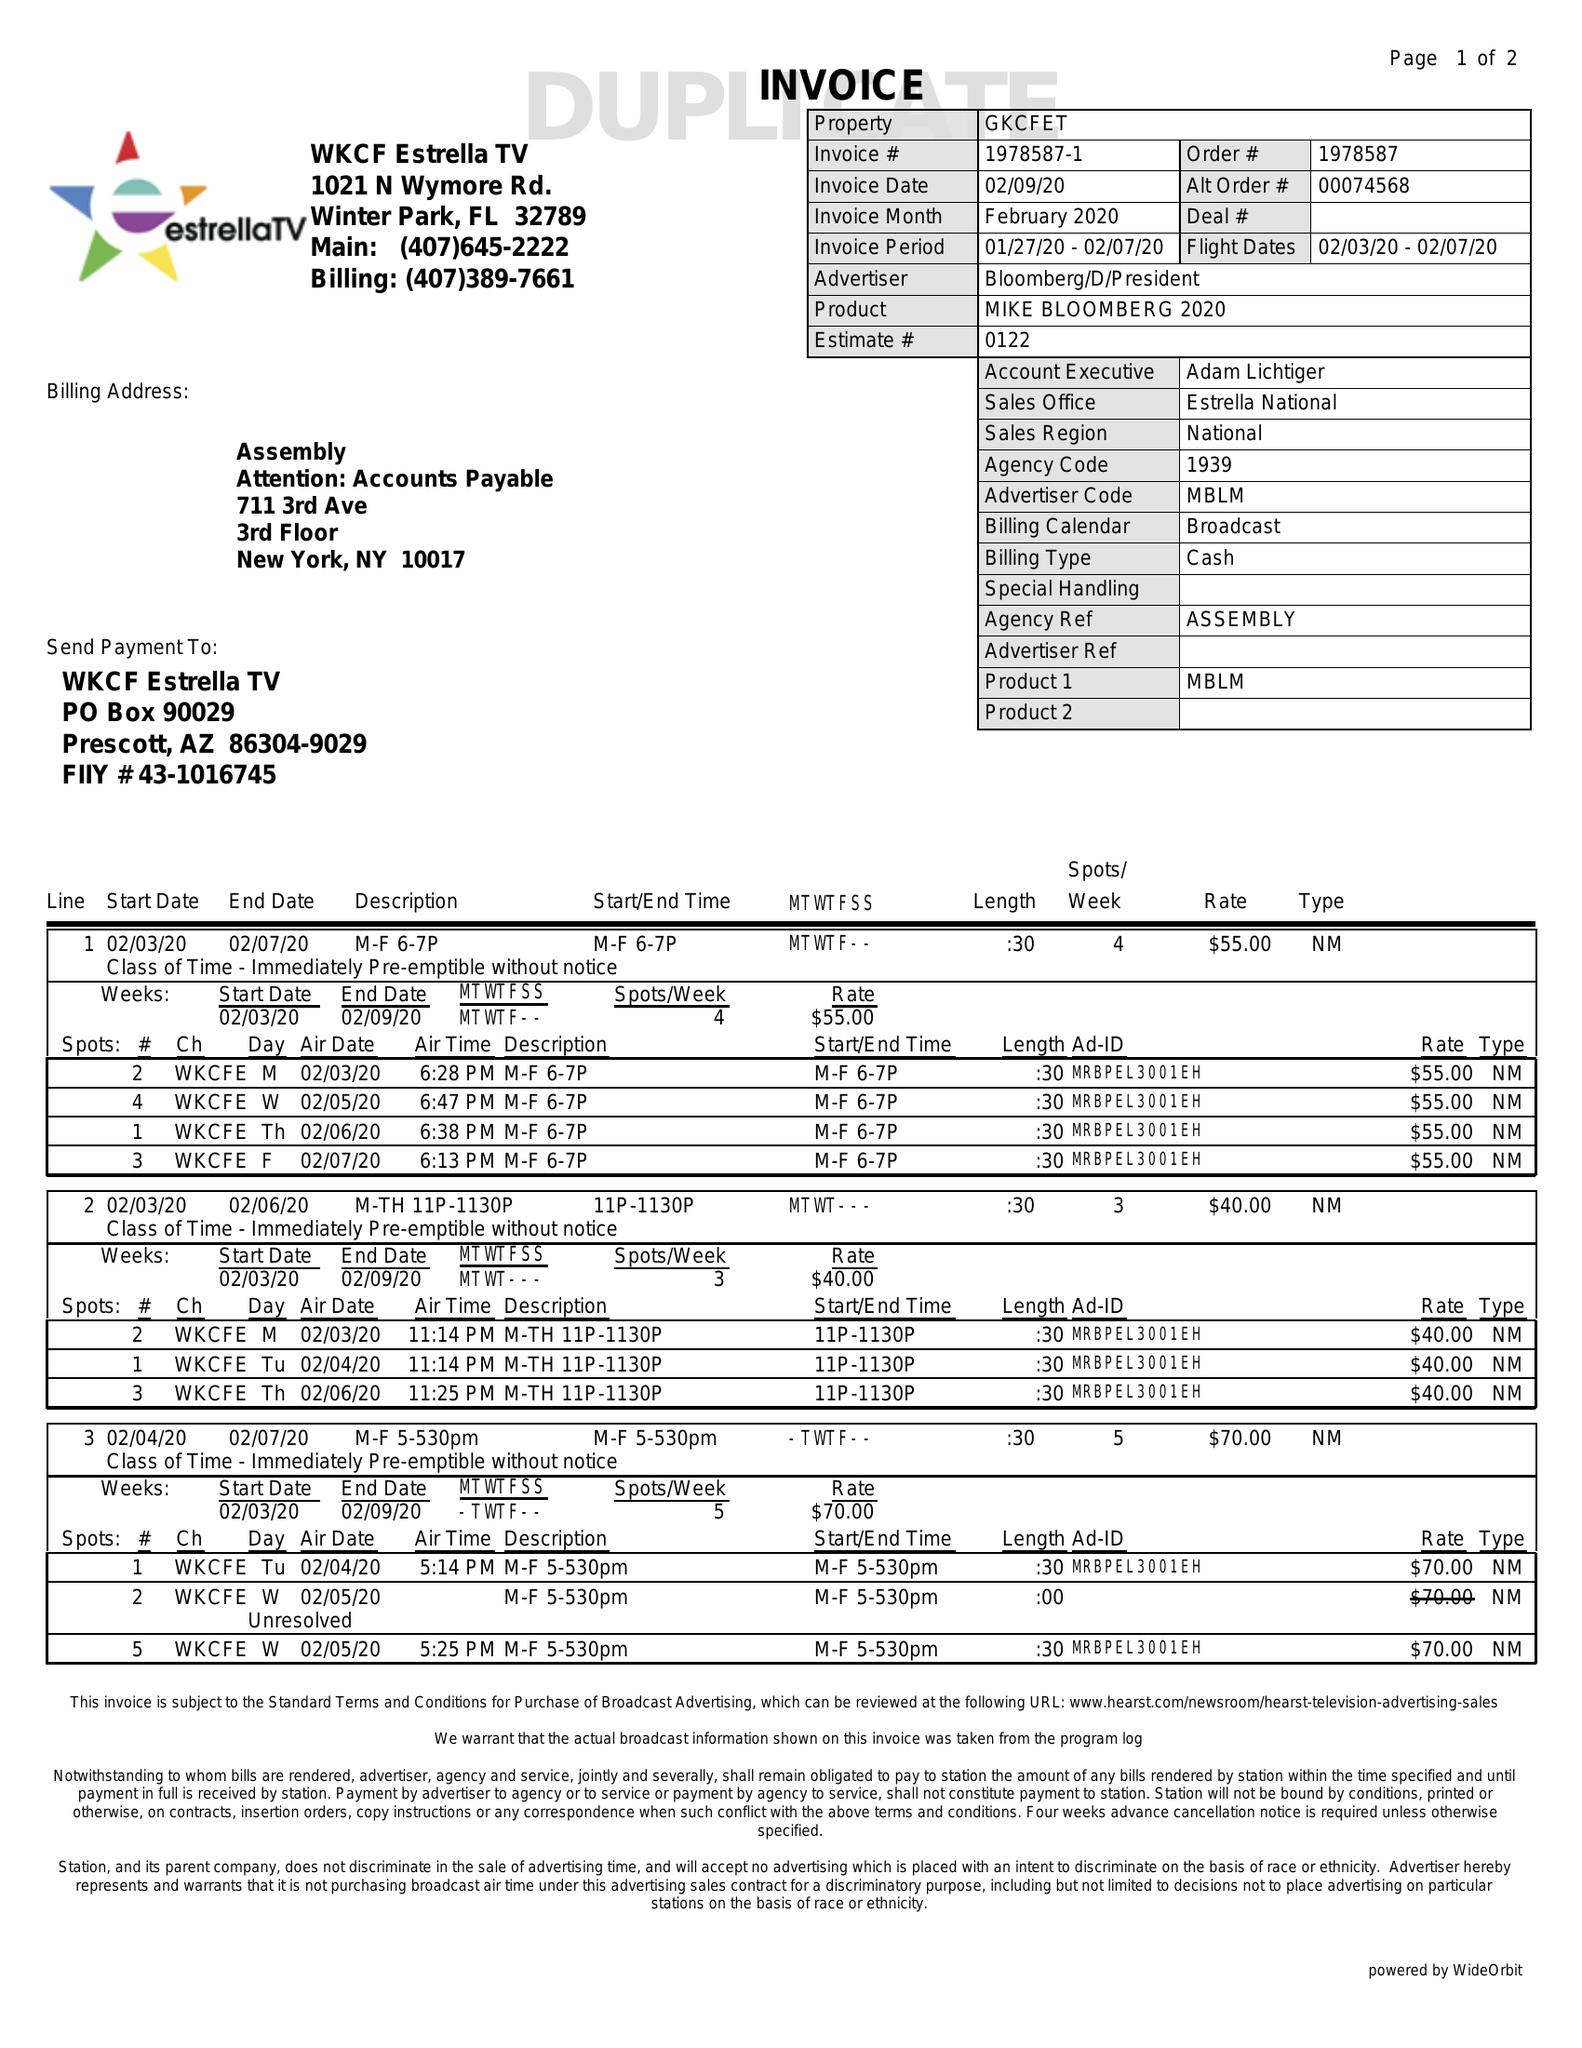What is the value for the flight_to?
Answer the question using a single word or phrase. 02/07/20 